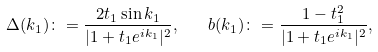<formula> <loc_0><loc_0><loc_500><loc_500>\Delta ( k _ { 1 } ) \colon = \frac { 2 t _ { 1 } \sin k _ { 1 } } { | 1 + t _ { 1 } e ^ { i k _ { 1 } } | ^ { 2 } } , \quad b ( k _ { 1 } ) \colon = \frac { 1 - t _ { 1 } ^ { 2 } } { | 1 + t _ { 1 } e ^ { i k _ { 1 } } | ^ { 2 } } ,</formula> 